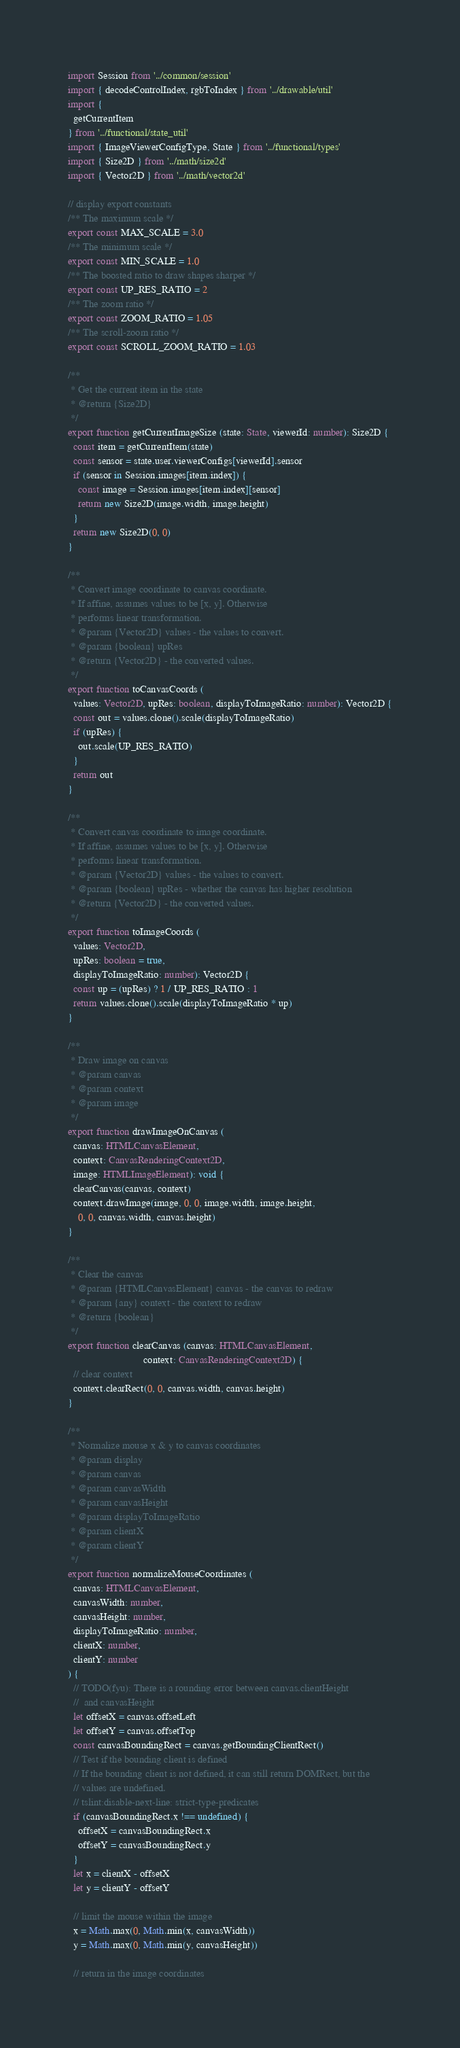Convert code to text. <code><loc_0><loc_0><loc_500><loc_500><_TypeScript_>import Session from '../common/session'
import { decodeControlIndex, rgbToIndex } from '../drawable/util'
import {
  getCurrentItem
} from '../functional/state_util'
import { ImageViewerConfigType, State } from '../functional/types'
import { Size2D } from '../math/size2d'
import { Vector2D } from '../math/vector2d'

// display export constants
/** The maximum scale */
export const MAX_SCALE = 3.0
/** The minimum scale */
export const MIN_SCALE = 1.0
/** The boosted ratio to draw shapes sharper */
export const UP_RES_RATIO = 2
/** The zoom ratio */
export const ZOOM_RATIO = 1.05
/** The scroll-zoom ratio */
export const SCROLL_ZOOM_RATIO = 1.03

/**
 * Get the current item in the state
 * @return {Size2D}
 */
export function getCurrentImageSize (state: State, viewerId: number): Size2D {
  const item = getCurrentItem(state)
  const sensor = state.user.viewerConfigs[viewerId].sensor
  if (sensor in Session.images[item.index]) {
    const image = Session.images[item.index][sensor]
    return new Size2D(image.width, image.height)
  }
  return new Size2D(0, 0)
}

/**
 * Convert image coordinate to canvas coordinate.
 * If affine, assumes values to be [x, y]. Otherwise
 * performs linear transformation.
 * @param {Vector2D} values - the values to convert.
 * @param {boolean} upRes
 * @return {Vector2D} - the converted values.
 */
export function toCanvasCoords (
  values: Vector2D, upRes: boolean, displayToImageRatio: number): Vector2D {
  const out = values.clone().scale(displayToImageRatio)
  if (upRes) {
    out.scale(UP_RES_RATIO)
  }
  return out
}

/**
 * Convert canvas coordinate to image coordinate.
 * If affine, assumes values to be [x, y]. Otherwise
 * performs linear transformation.
 * @param {Vector2D} values - the values to convert.
 * @param {boolean} upRes - whether the canvas has higher resolution
 * @return {Vector2D} - the converted values.
 */
export function toImageCoords (
  values: Vector2D,
  upRes: boolean = true,
  displayToImageRatio: number): Vector2D {
  const up = (upRes) ? 1 / UP_RES_RATIO : 1
  return values.clone().scale(displayToImageRatio * up)
}

/**
 * Draw image on canvas
 * @param canvas
 * @param context
 * @param image
 */
export function drawImageOnCanvas (
  canvas: HTMLCanvasElement,
  context: CanvasRenderingContext2D,
  image: HTMLImageElement): void {
  clearCanvas(canvas, context)
  context.drawImage(image, 0, 0, image.width, image.height,
    0, 0, canvas.width, canvas.height)
}

/**
 * Clear the canvas
 * @param {HTMLCanvasElement} canvas - the canvas to redraw
 * @param {any} context - the context to redraw
 * @return {boolean}
 */
export function clearCanvas (canvas: HTMLCanvasElement,
                             context: CanvasRenderingContext2D) {
  // clear context
  context.clearRect(0, 0, canvas.width, canvas.height)
}

/**
 * Normalize mouse x & y to canvas coordinates
 * @param display
 * @param canvas
 * @param canvasWidth
 * @param canvasHeight
 * @param displayToImageRatio
 * @param clientX
 * @param clientY
 */
export function normalizeMouseCoordinates (
  canvas: HTMLCanvasElement,
  canvasWidth: number,
  canvasHeight: number,
  displayToImageRatio: number,
  clientX: number,
  clientY: number
) {
  // TODO(fyu): There is a rounding error between canvas.clientHeight
  //  and canvasHeight
  let offsetX = canvas.offsetLeft
  let offsetY = canvas.offsetTop
  const canvasBoundingRect = canvas.getBoundingClientRect()
  // Test if the bounding client is defined
  // If the bounding client is not defined, it can still return DOMRect, but the
  // values are undefined.
  // tslint:disable-next-line: strict-type-predicates
  if (canvasBoundingRect.x !== undefined) {
    offsetX = canvasBoundingRect.x
    offsetY = canvasBoundingRect.y
  }
  let x = clientX - offsetX
  let y = clientY - offsetY

  // limit the mouse within the image
  x = Math.max(0, Math.min(x, canvasWidth))
  y = Math.max(0, Math.min(y, canvasHeight))

  // return in the image coordinates</code> 